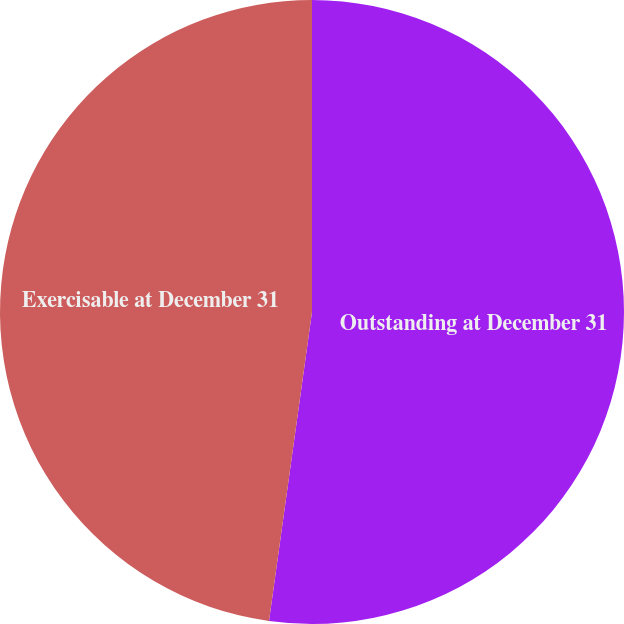Convert chart. <chart><loc_0><loc_0><loc_500><loc_500><pie_chart><fcel>Outstanding at December 31<fcel>Exercisable at December 31<nl><fcel>52.2%<fcel>47.8%<nl></chart> 